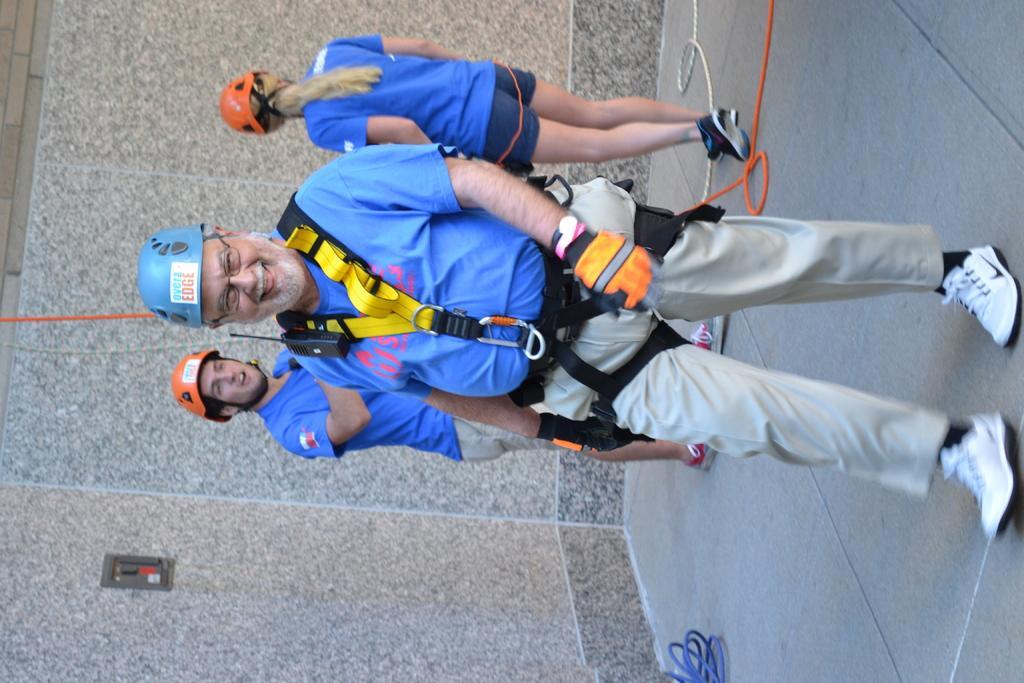Can you describe this image briefly? In the center of the image we can see three people are standing and wearing blue T-shirts, helmets. On the left side of the image we can see the wall. On the right side of the image we can see the floor and ropes. 